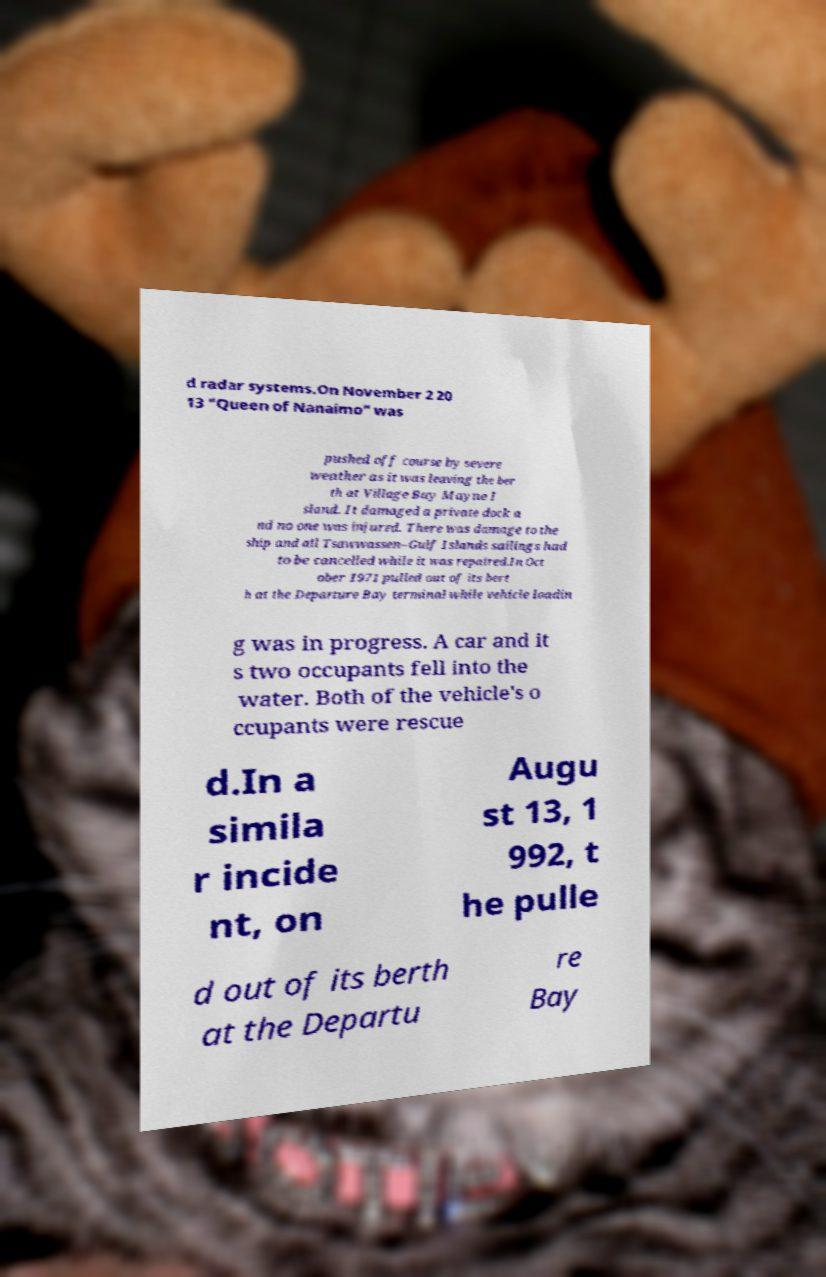I need the written content from this picture converted into text. Can you do that? d radar systems.On November 2 20 13 "Queen of Nanaimo" was pushed off course by severe weather as it was leaving the ber th at Village Bay Mayne I sland. It damaged a private dock a nd no one was injured. There was damage to the ship and all Tsawwassen–Gulf Islands sailings had to be cancelled while it was repaired.In Oct ober 1971 pulled out of its bert h at the Departure Bay terminal while vehicle loadin g was in progress. A car and it s two occupants fell into the water. Both of the vehicle's o ccupants were rescue d.In a simila r incide nt, on Augu st 13, 1 992, t he pulle d out of its berth at the Departu re Bay 